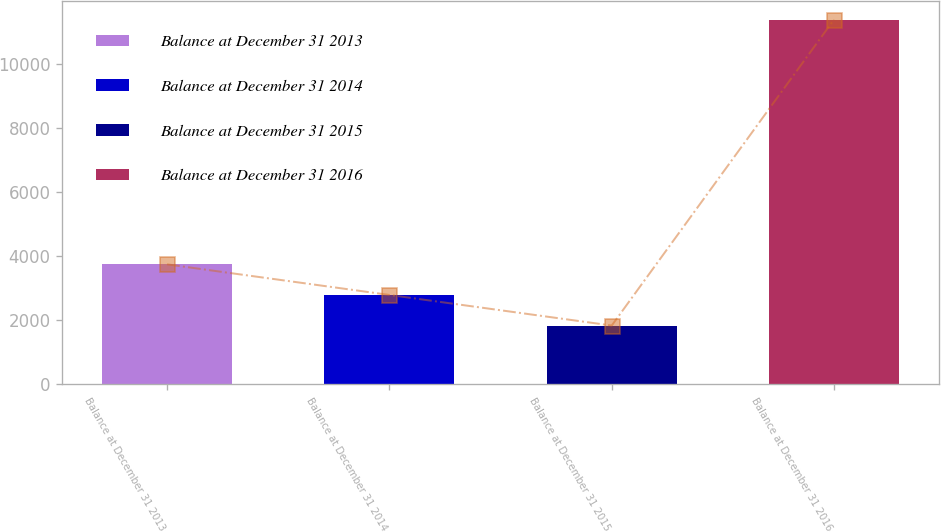Convert chart. <chart><loc_0><loc_0><loc_500><loc_500><bar_chart><fcel>Balance at December 31 2013<fcel>Balance at December 31 2014<fcel>Balance at December 31 2015<fcel>Balance at December 31 2016<nl><fcel>3738<fcel>2782.2<fcel>1826.4<fcel>11384.4<nl></chart> 